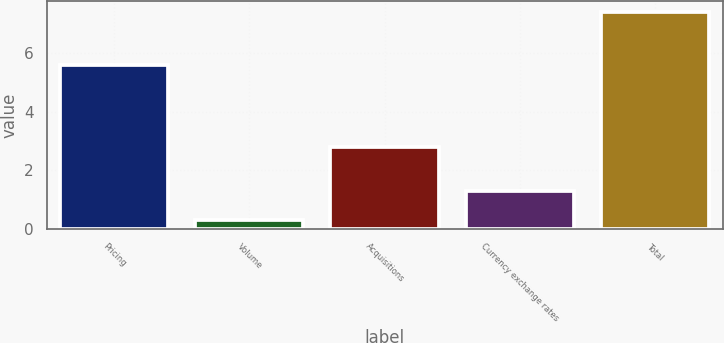Convert chart. <chart><loc_0><loc_0><loc_500><loc_500><bar_chart><fcel>Pricing<fcel>Volume<fcel>Acquisitions<fcel>Currency exchange rates<fcel>Total<nl><fcel>5.6<fcel>0.3<fcel>2.8<fcel>1.3<fcel>7.4<nl></chart> 